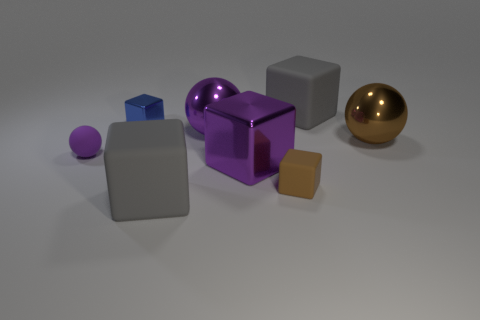Subtract all purple cubes. How many cubes are left? 4 Subtract all small blue cubes. How many cubes are left? 4 Subtract all red cubes. Subtract all cyan cylinders. How many cubes are left? 5 Add 1 small rubber cubes. How many objects exist? 9 Subtract all spheres. How many objects are left? 5 Add 2 purple matte things. How many purple matte things are left? 3 Add 7 tiny purple objects. How many tiny purple objects exist? 8 Subtract 0 red cubes. How many objects are left? 8 Subtract all small blocks. Subtract all purple spheres. How many objects are left? 4 